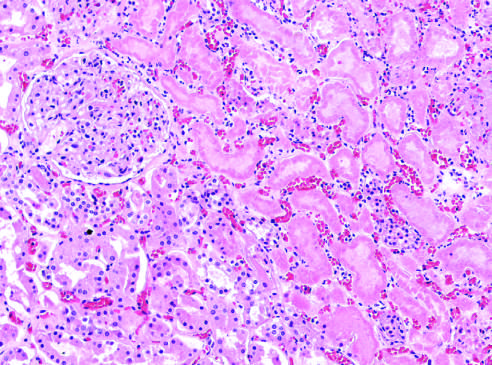do the necrotic cells show preserved outlines with loss of nuclei?
Answer the question using a single word or phrase. Yes 